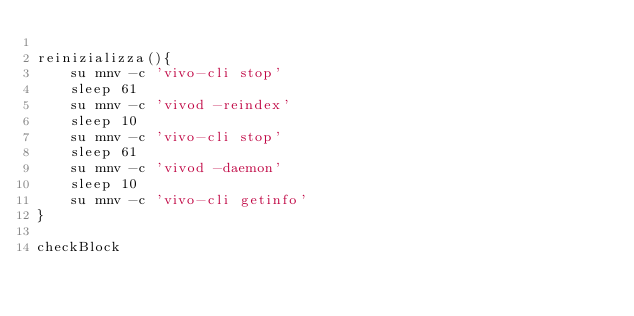Convert code to text. <code><loc_0><loc_0><loc_500><loc_500><_Bash_>
reinizializza(){
	su mnv -c 'vivo-cli stop'
	sleep 61
	su mnv -c 'vivod -reindex'
	sleep 10
	su mnv -c 'vivo-cli stop'
	sleep 61
	su mnv -c 'vivod -daemon'
	sleep 10
	su mnv -c 'vivo-cli getinfo'
}

checkBlock
</code> 